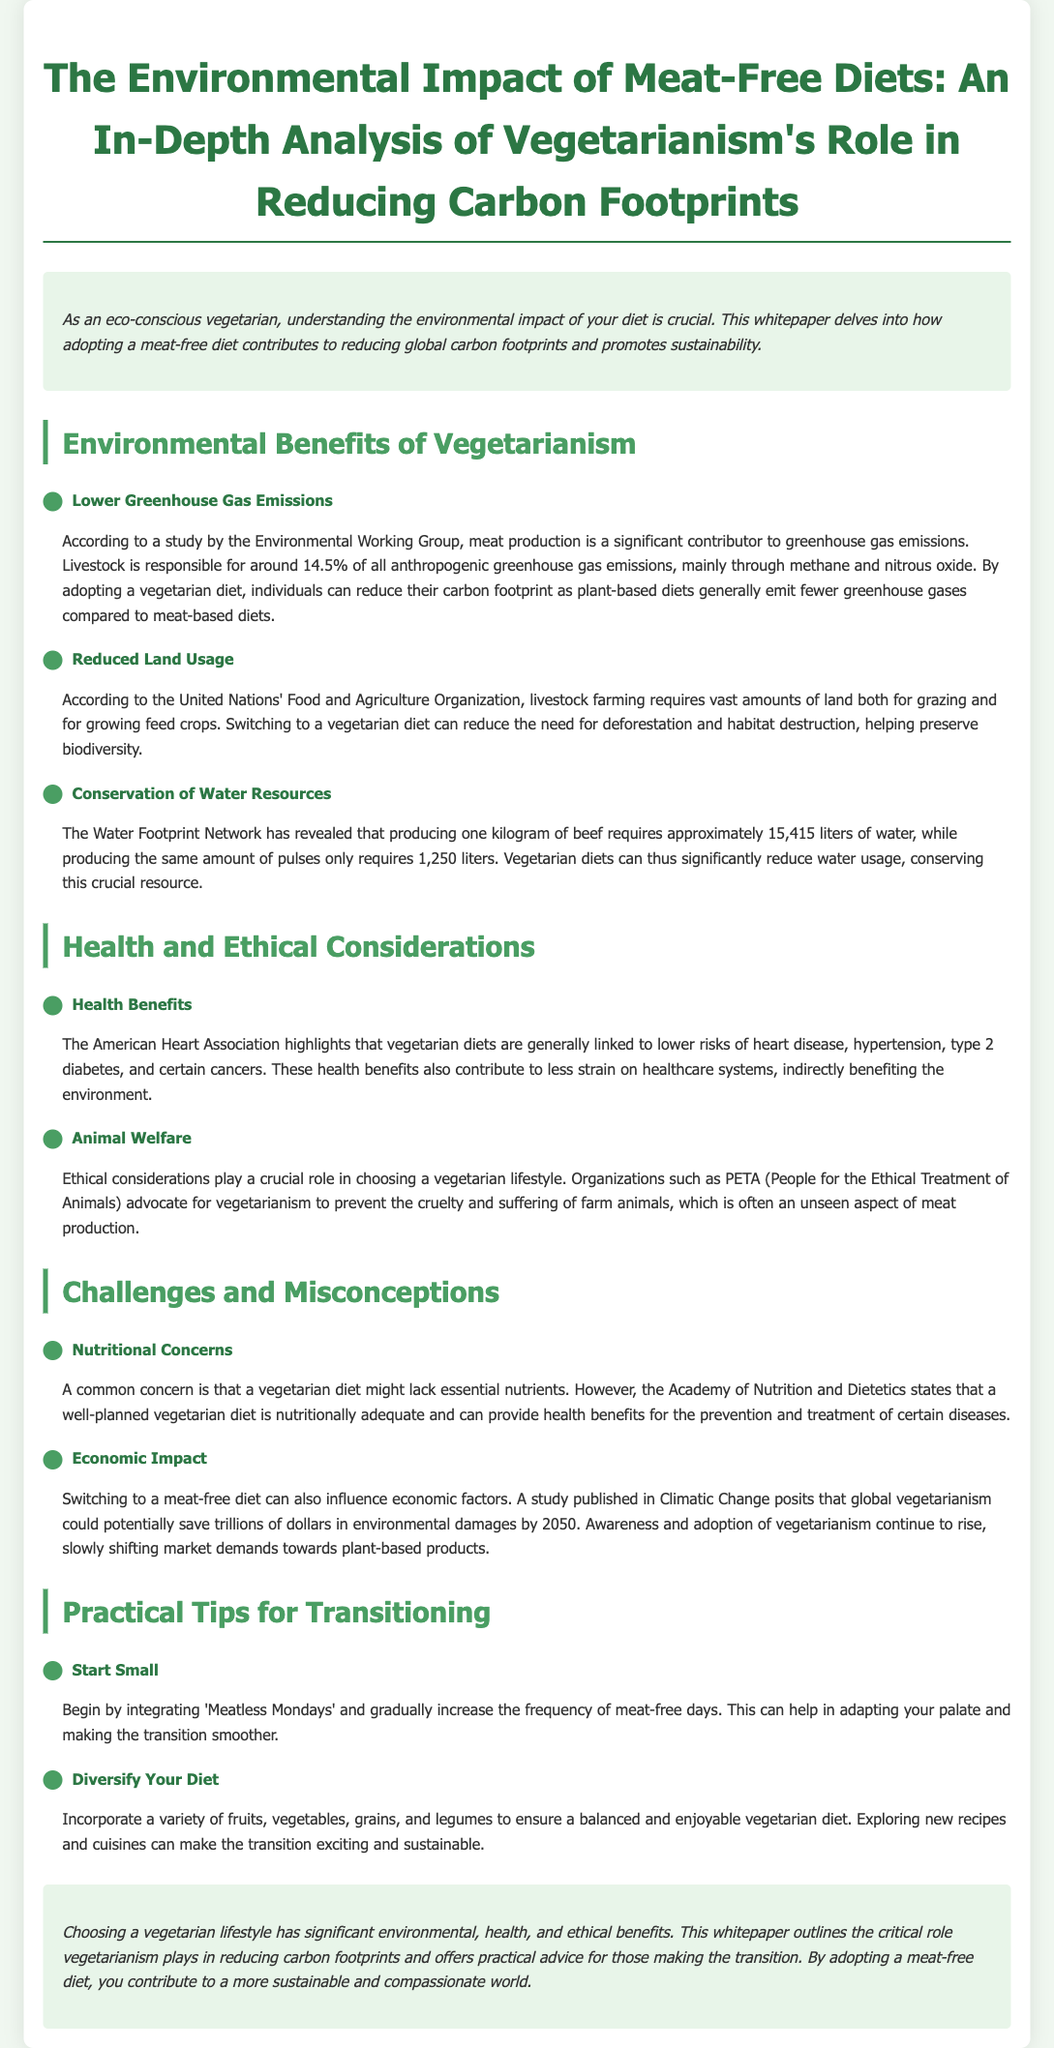What percentage of anthropogenic greenhouse gas emissions is livestock responsible for? The document states that livestock is responsible for around 14.5% of all anthropogenic greenhouse gas emissions.
Answer: 14.5% What is the water requirement for producing one kilogram of beef? The document mentions that producing one kilogram of beef requires approximately 15,415 liters of water.
Answer: 15,415 liters What organization highlights the health benefits of vegetarian diets? The American Heart Association is mentioned as highlighting the health benefits associated with vegetarian diets.
Answer: American Heart Association What is one practical tip for transitioning to a vegetarian diet? The document suggests starting with 'Meatless Mondays' as a practical tip for transitioning.
Answer: Meatless Mondays Which study suggests that global vegetarianism could save trillions of dollars? The study published in Climatic Change is referred to regarding economic impact and potential savings from global vegetarianism.
Answer: Climatic Change How many liters of water are required to produce the same amount of pulses as one kilogram of beef? The document states that producing the same amount of pulses only requires 1,250 liters of water.
Answer: 1,250 liters What is the main ethical consideration for choosing a vegetarian lifestyle? The document states that animal welfare is a crucial ethical consideration in choosing a vegetarian lifestyle.
Answer: Animal welfare What should be incorporated into a vegetarian diet for balance? The document emphasizes incorporating a variety of fruits, vegetables, grains, and legumes for a balanced vegetarian diet.
Answer: Fruits, vegetables, grains, and legumes 